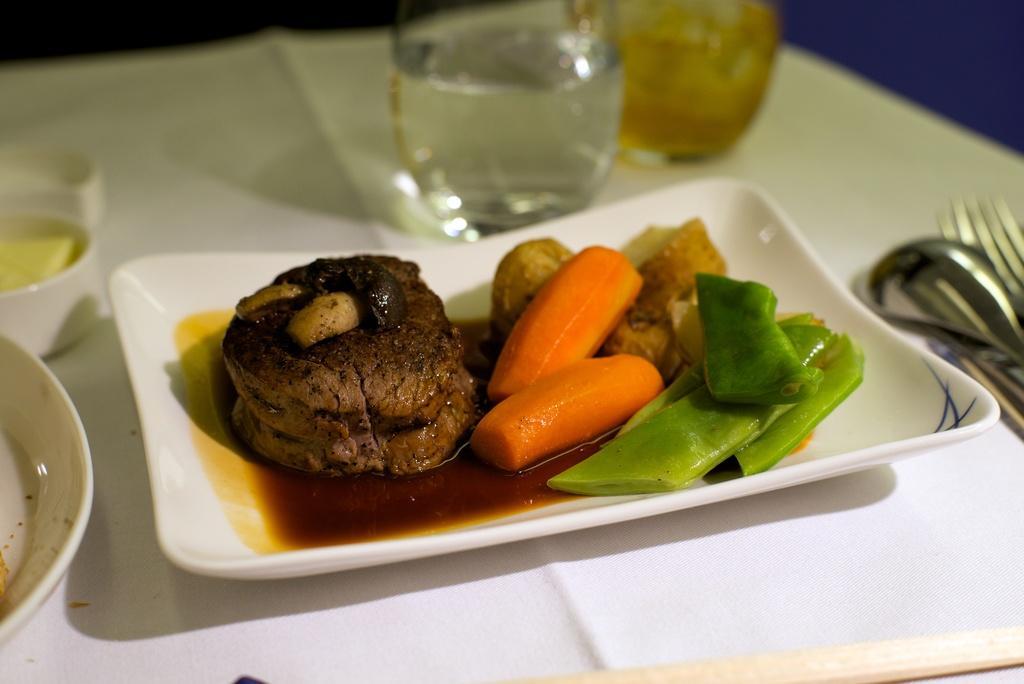Can you describe this image briefly? In this picture we can see food items in a plate, here we can see a spoon, forks and some objects and these all are on the platform. 